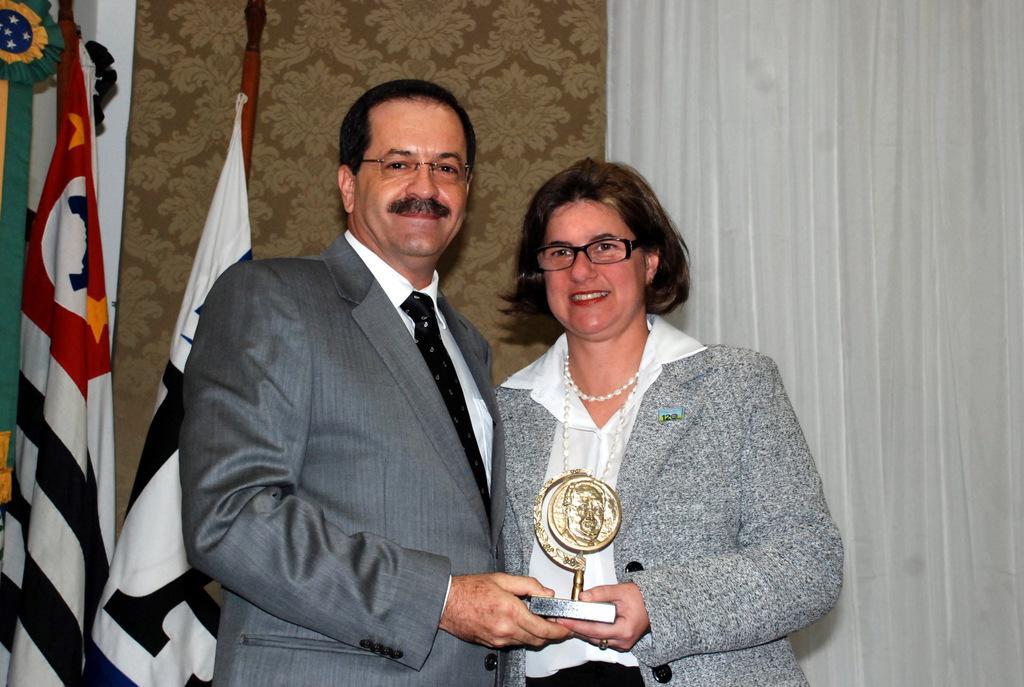Can you describe this image briefly? This picture is clicked inside. On the left there is a man wearing suit, smiling, standing and holding an object and we can see a woman wearing a blazer, smiling, standing and holding an object. In the background we can see the wall, curtain and flags. 